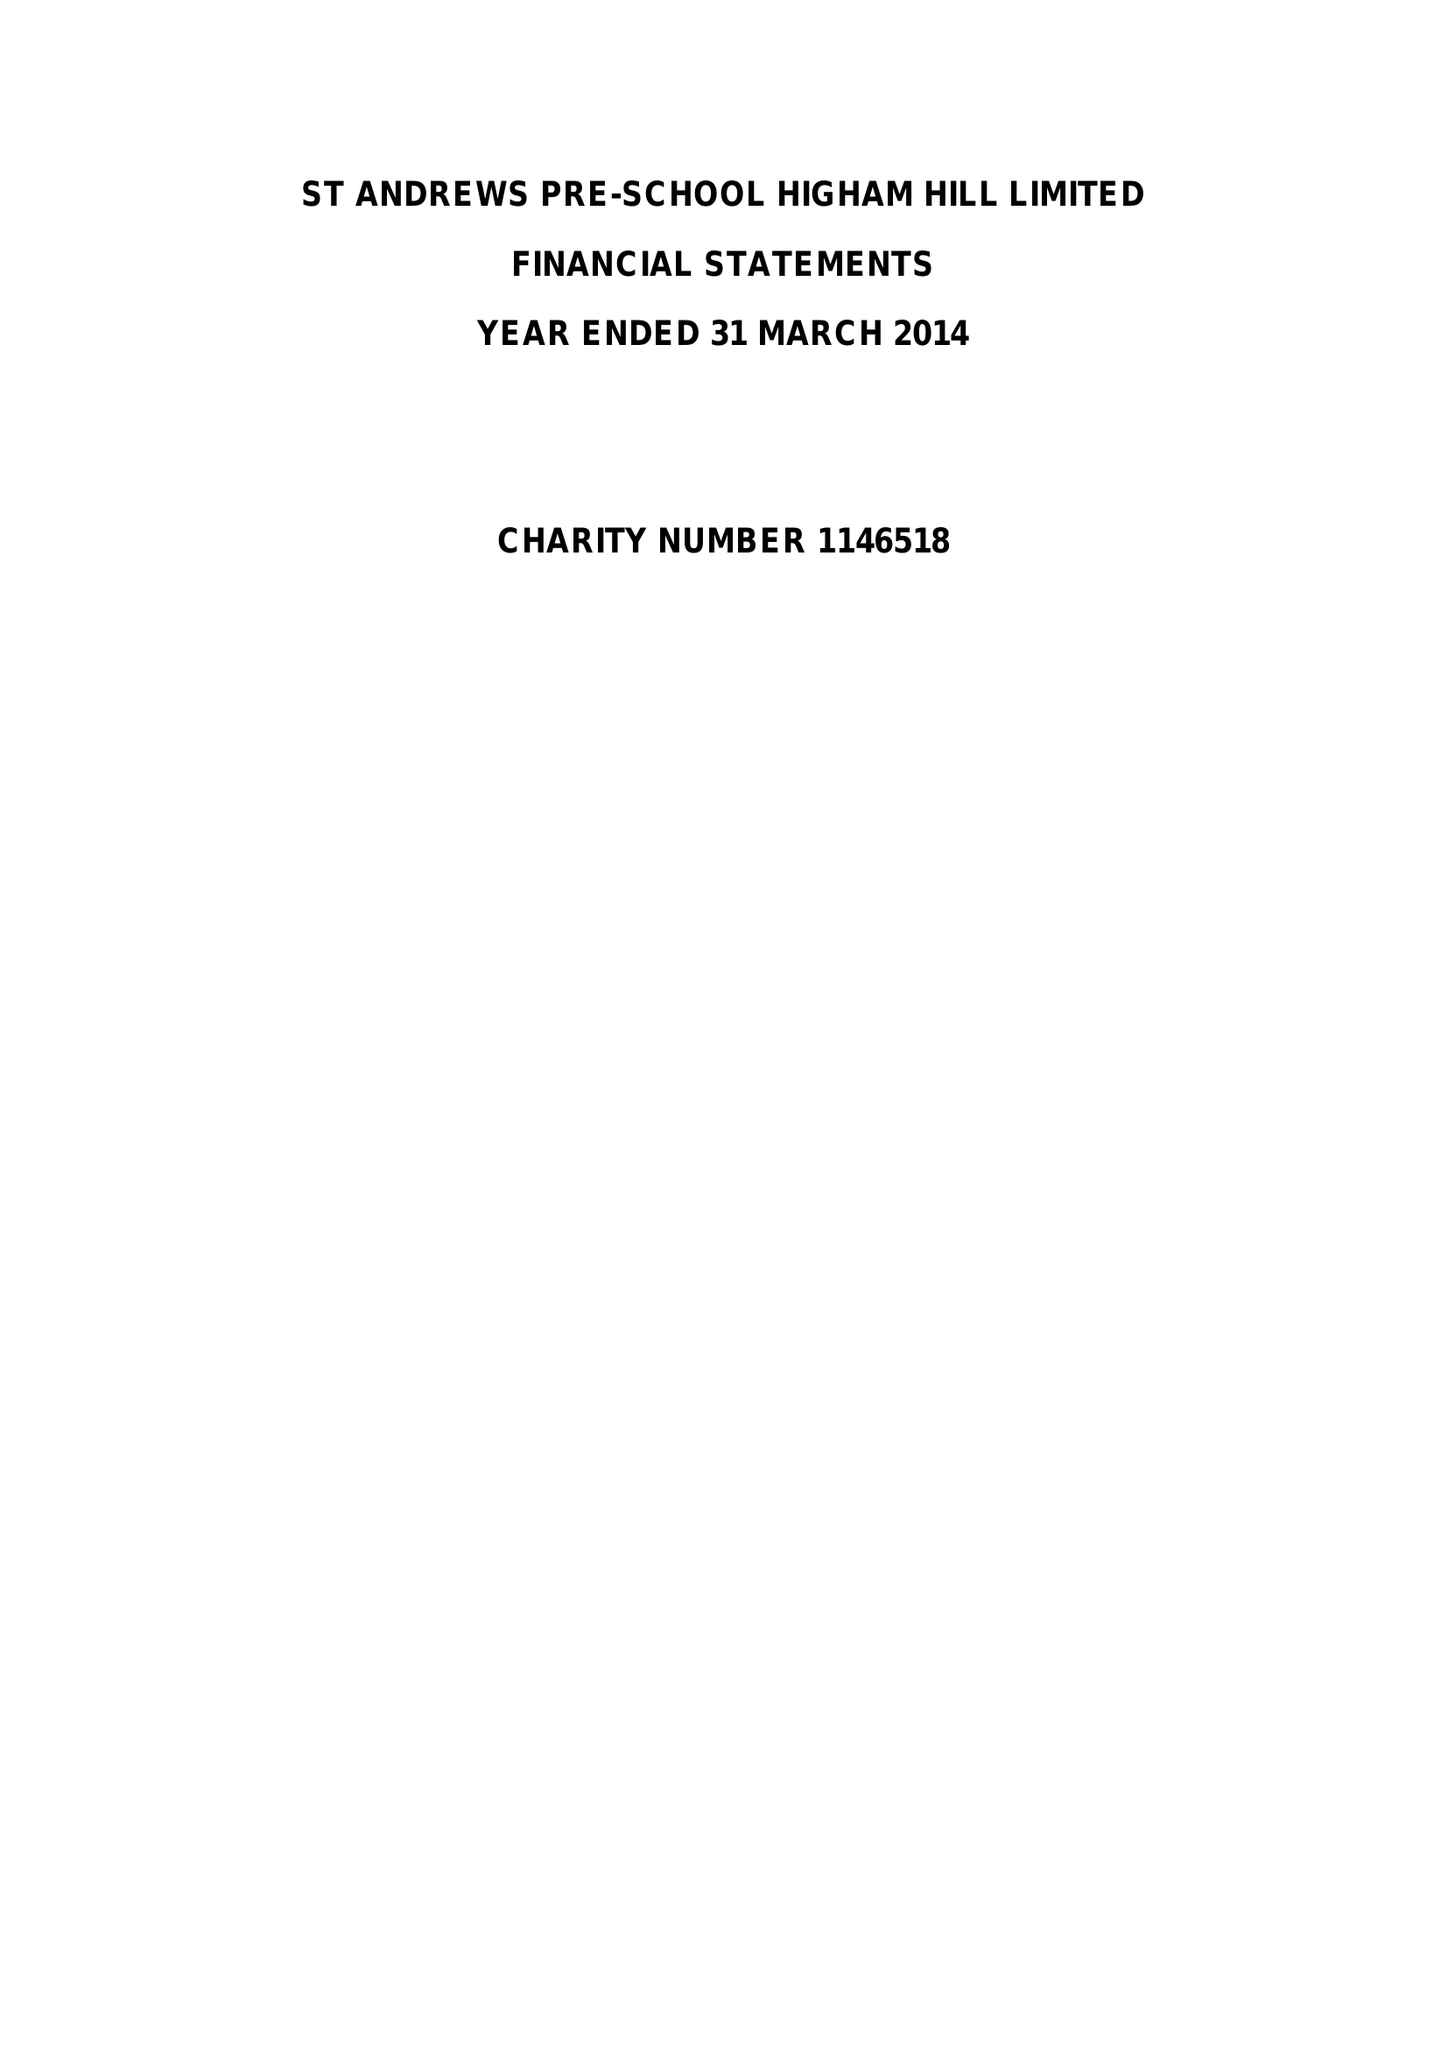What is the value for the charity_name?
Answer the question using a single word or phrase. St.Andrews Pre-School Higham Hill Ltd. 